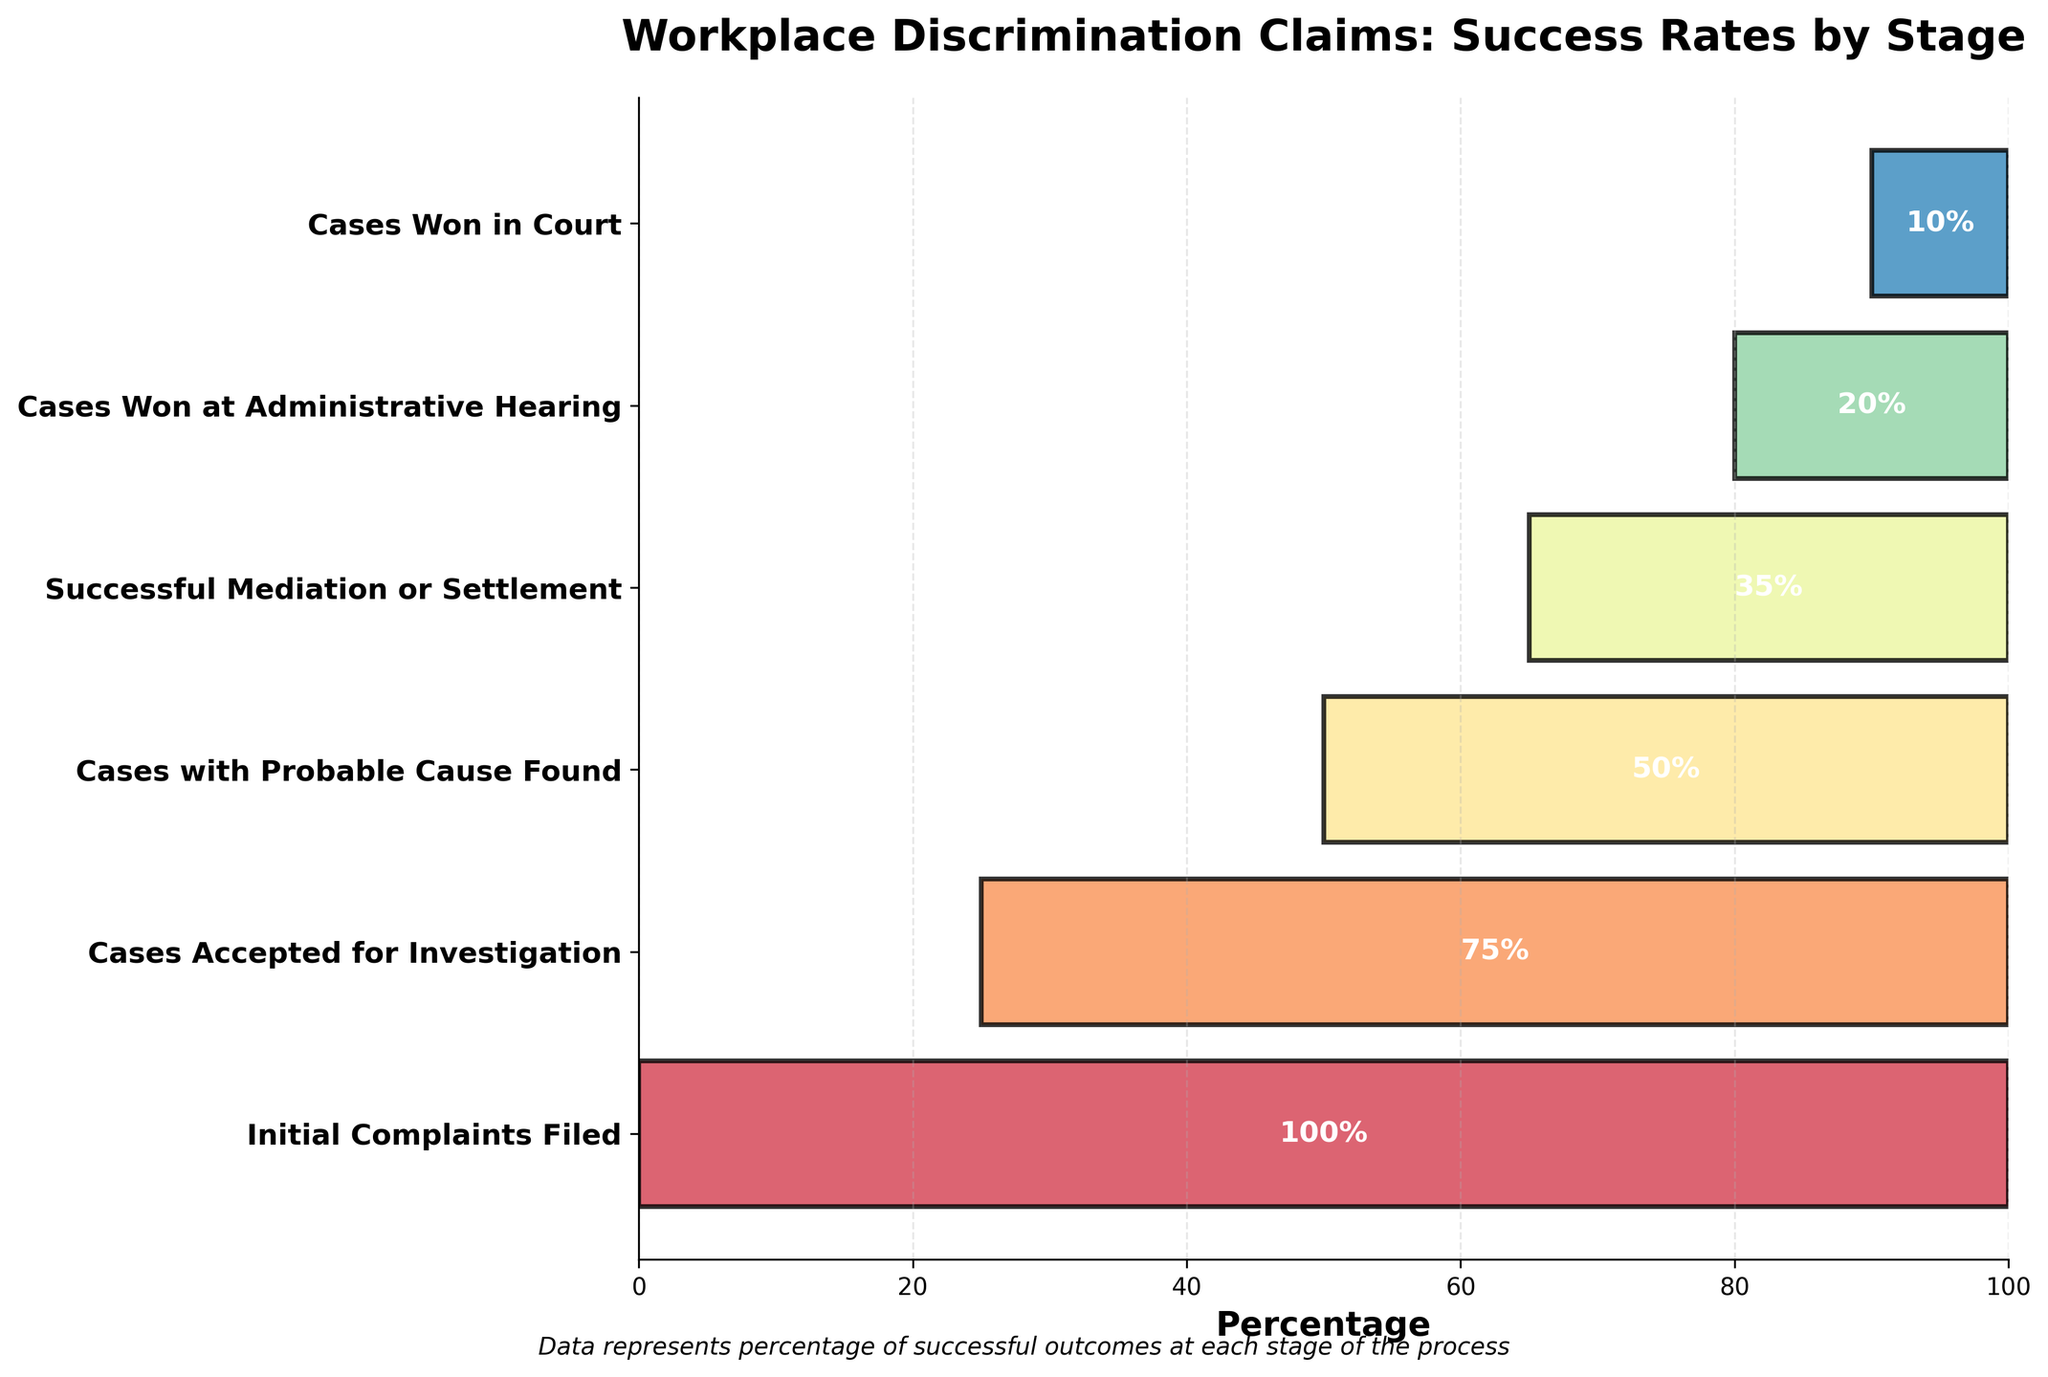What is the title of the chart? The title is usually found at the top of the figure and describes what the chart is about. In this chart, the title is "Workplace Discrimination Claims: Success Rates by Stage."
Answer: Workplace Discrimination Claims: Success Rates by Stage What percentage of initial complaints filed are eventually won in court? Look at the initial percentage for "Initial Complaints Filed" (100%) and compare it with the percentage for "Cases Won in Court" (10%). This comparison shows that only 10% of the initial complaints filed are eventually won in court.
Answer: 10% Which stage has the steepest drop in success rate? The steepest drop is found where the difference between consecutive stages is the largest. Compare the percentage drop between each pair of stages:
- 100% to 75% (25%)
- 75% to 50% (25%)
- 50% to 35% (15%)
- 35% to 20% (15%)
- 20% to 10% (10%)
The drop from "Initial Complaints Filed" to "Cases Accepted for Investigation" and "Cases Accepted for Investigation" to "Cases with Probable Cause Found" both have the steepest drop of 25%.
Answer: Initial Complaints Filed to Cases Accepted for Investigation, or Cases Accepted for Investigation to Cases with Probable Cause Found What is the sum of the percentages for the successful mediation or settlement and cases won at administrative hearing stages? Add the percentages of both stages: 35% (Successful Mediation or Settlement) + 20% (Cases Won at Administrative Hearing).
Answer: 55% Which stage shows a success rate reduction of less than 20 percentage points from the previous stage? Compare the percentage reductions between consecutive stages, looking for reductions less than 20 points:
- Initial Complaints Filed to Cases Accepted for Investigation: 100% to 75% (25 points)
- Cases Accepted for Investigation to Cases with Probable Cause Found: 75% to 50% (25 points)
- Cases with Probable Cause Found to Successful Mediation or Settlement: 50% to 35% (15 points)
- Successful Mediation or Settlement to Cases Won at Administrative Hearing: 35% to 20% (15 points)
- Cases Won at Administrative Hearing to Cases Won in Court: 20% to 10% (10 points)
The reductions from "Cases with Probable Cause Found" to "Successful Mediation or Settlement," "Successful Mediation or Settlement" to "Cases Won at Administrative Hearing," and "Cases Won at Administrative Hearing" to "Cases Won in Court" are all less than 20 points.
Answer: Cases with Probable Cause Found to Successful Mediation or Settlement, Successful Mediation or Settlement to Cases Won at Administrative Hearing, Cases Won at Administrative Hearing to Cases Won in Court How many stages are represented in the chart? Count the number of labels on the y-axis, which each represent a stage.
Answer: 6 Which stage has the lowest success rate? Identify the stage with the smallest percentage on the x-axis. "Cases Won in Court" has the lowest success rate at 10%.
Answer: Cases Won in Court What is the average success rate of all the stages? Add all the percentages and divide by the number of stages:
(100% + 75% + 50% + 35% + 20% + 10%) / 6 = 290% / 6 = 48.33%
Answer: 48.33% Which two consecutive stages have the smallest drop in success rate? Identify the pairs of consecutive stages and find the smallest difference:
- Initial Complaints Filed to Cases Accepted for Investigation: 25%
- Cases Accepted for Investigation to Cases with Probable Cause Found: 25%
- Cases with Probable Cause Found to Successful Mediation or Settlement: 15%
- Successful Mediation or Settlement to Cases Won at Administrative Hearing: 15%
- Cases Won at Administrative Hearing to Cases Won in Court: 10%
The pair with the smallest drop is "Cases Won at Administrative Hearing" to "Cases Won in Court," with a drop of 10%.
Answer: Cases Won at Administrative Hearing to Cases Won in Court 